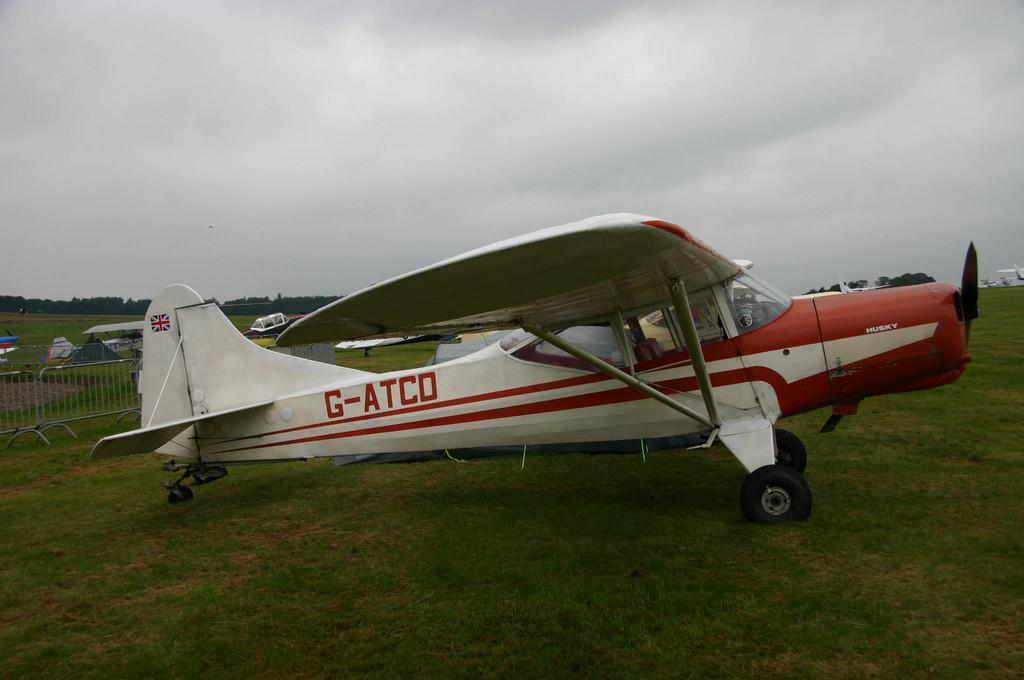<image>
Summarize the visual content of the image. A white and red airplane is parked with G-ATCO on the side. 